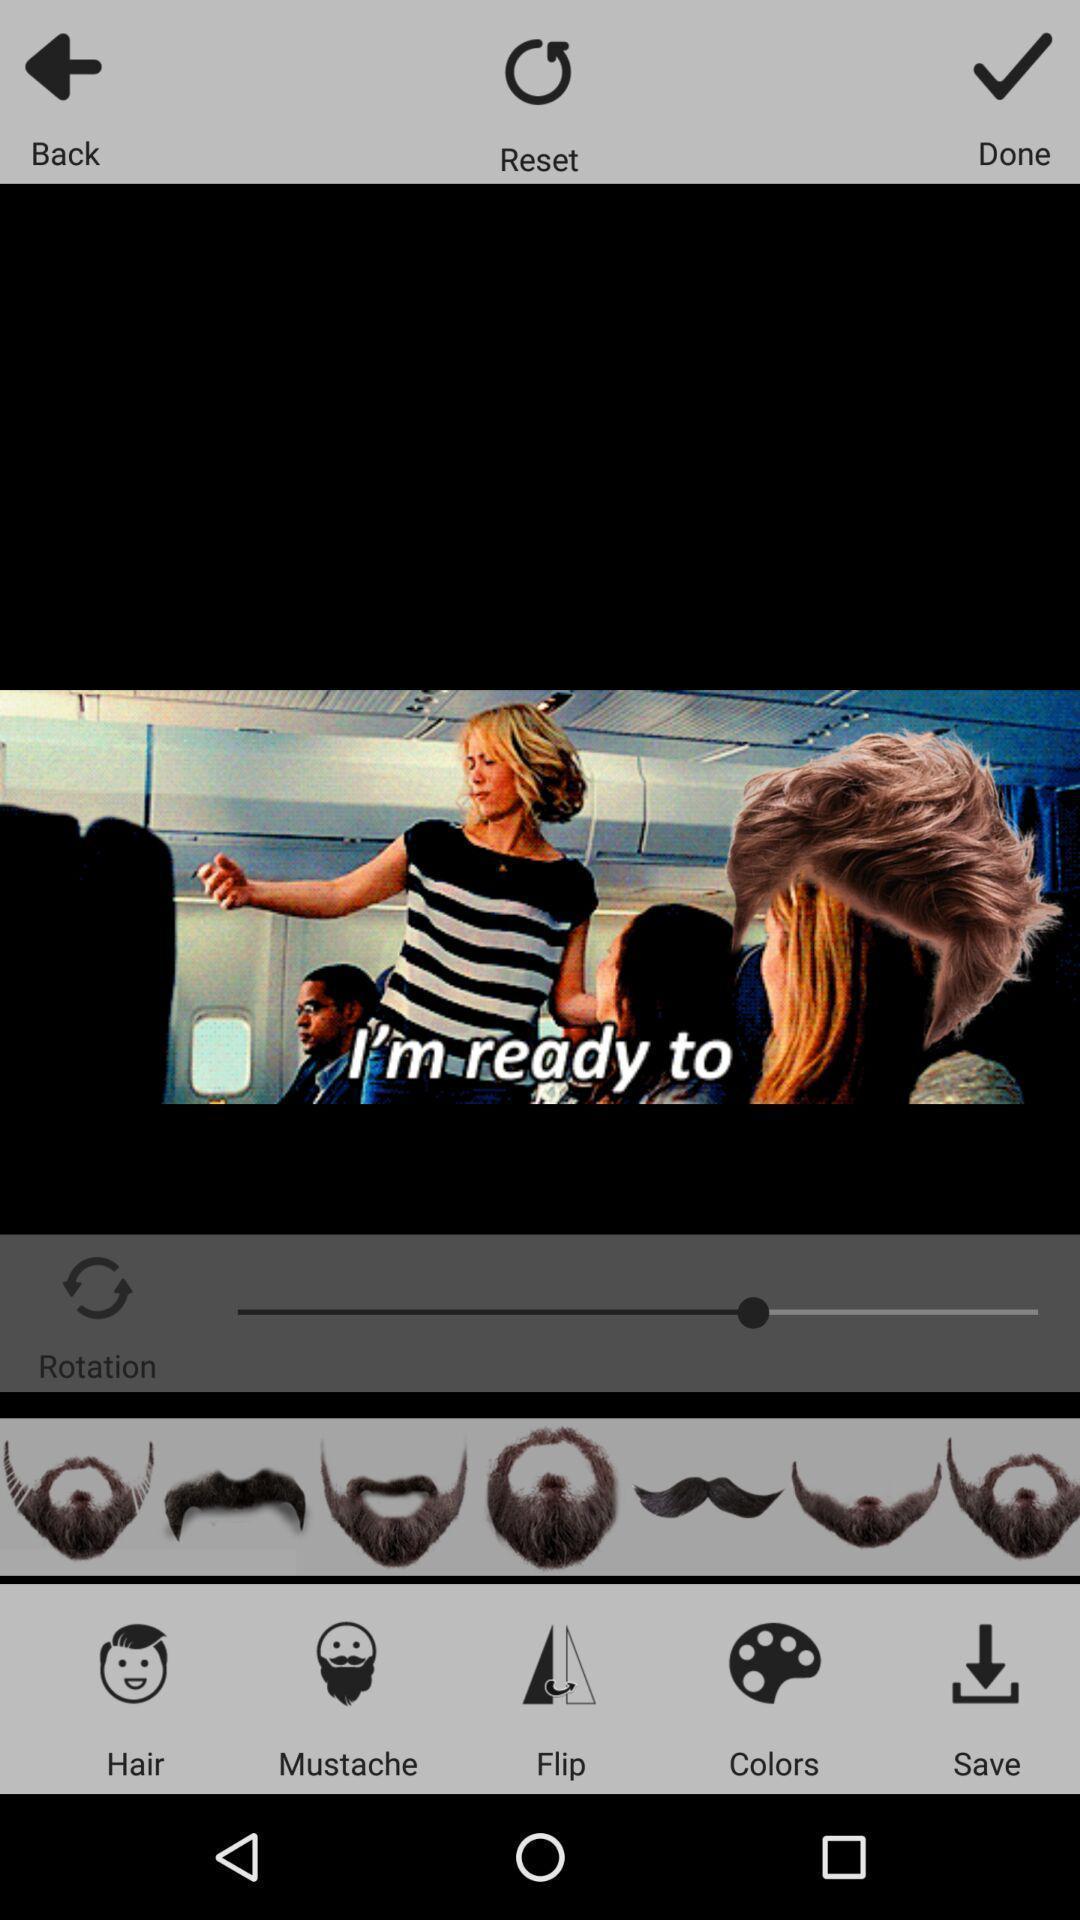Tell me what you see in this picture. Page displaying to apply filters of an editing application. 